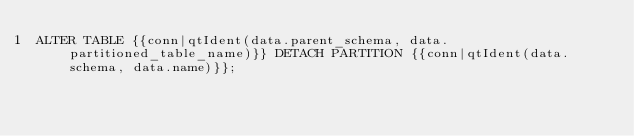Convert code to text. <code><loc_0><loc_0><loc_500><loc_500><_SQL_>ALTER TABLE {{conn|qtIdent(data.parent_schema, data.partitioned_table_name)}} DETACH PARTITION {{conn|qtIdent(data.schema, data.name)}};
</code> 